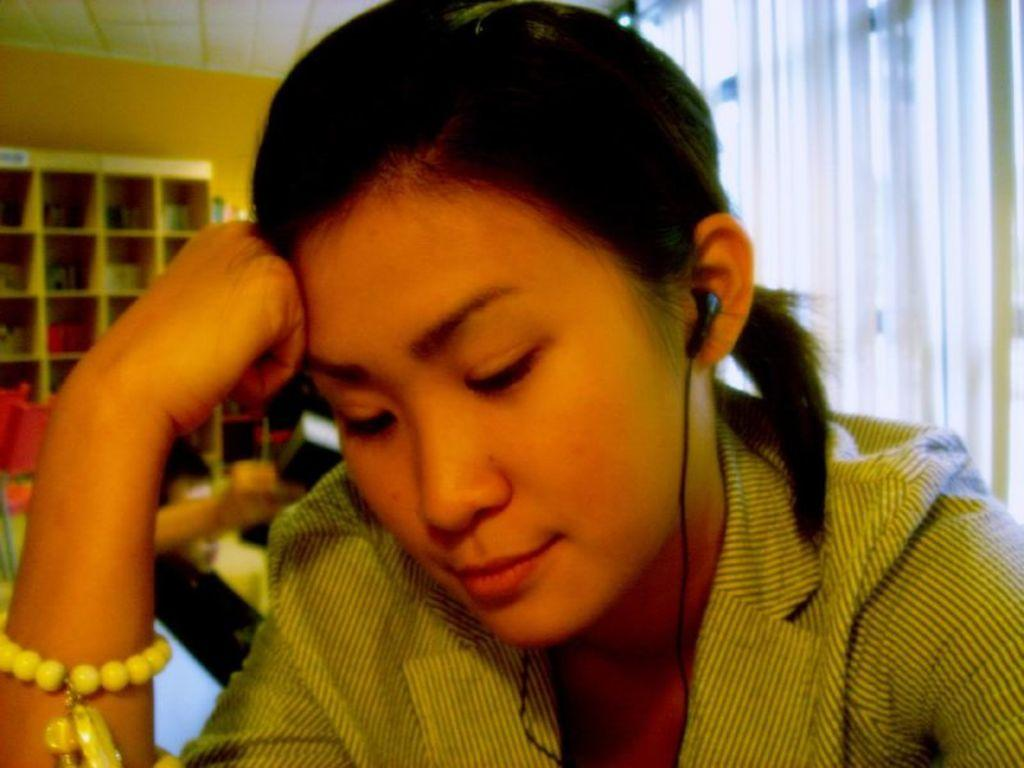What is the main subject of the image? There is a person in the image. Can you describe the person's attire? The person is wearing a dress. What is the person doing in the image? The person is wearing earphones. Can you describe the background of the image? There is another person in the background, a cupboard with objects, curtains, and a wall visible. What type of bait is the person using to catch fish in the image? There is no indication of fishing or bait in the image; the person is wearing earphones and is likely engaged in a different activity. 